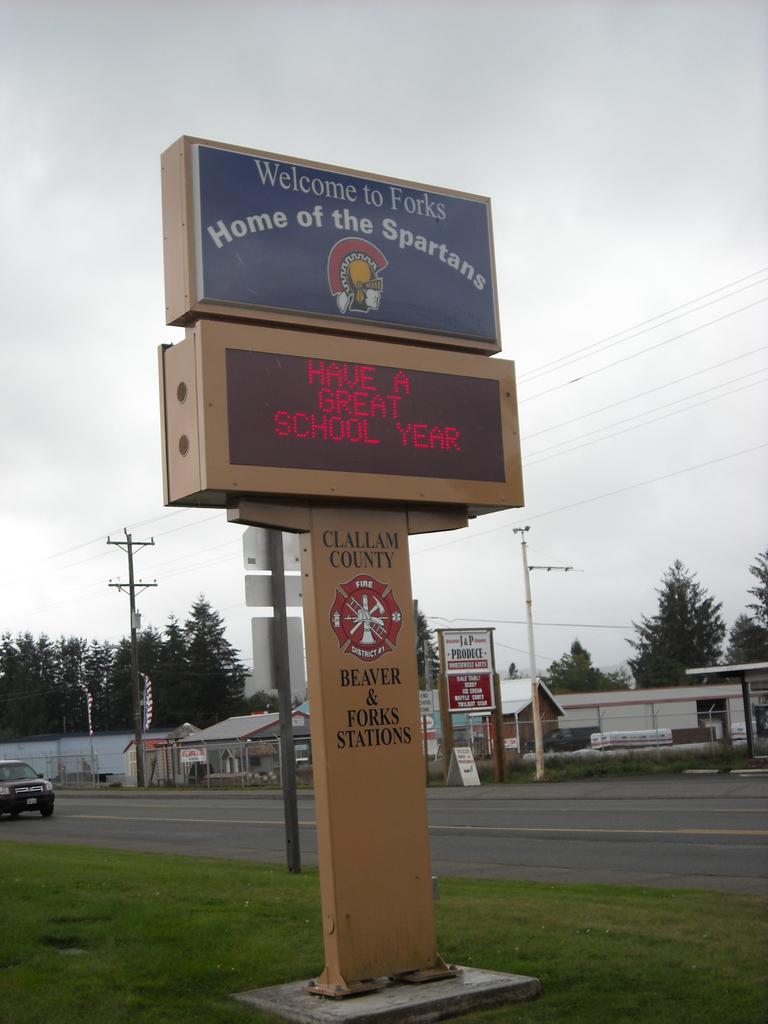What is the schools mascot?
Ensure brevity in your answer.  Spartans. What does the sign welcome you to?
Your answer should be compact. Forks. 